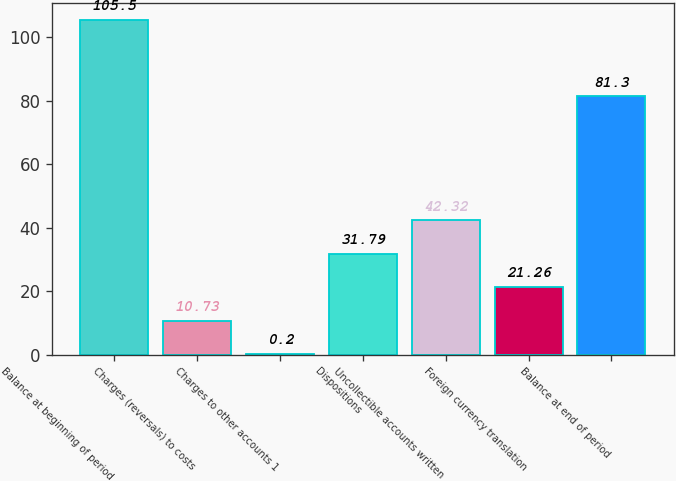Convert chart to OTSL. <chart><loc_0><loc_0><loc_500><loc_500><bar_chart><fcel>Balance at beginning of period<fcel>Charges (reversals) to costs<fcel>Charges to other accounts 1<fcel>Dispositions<fcel>Uncollectible accounts written<fcel>Foreign currency translation<fcel>Balance at end of period<nl><fcel>105.5<fcel>10.73<fcel>0.2<fcel>31.79<fcel>42.32<fcel>21.26<fcel>81.3<nl></chart> 